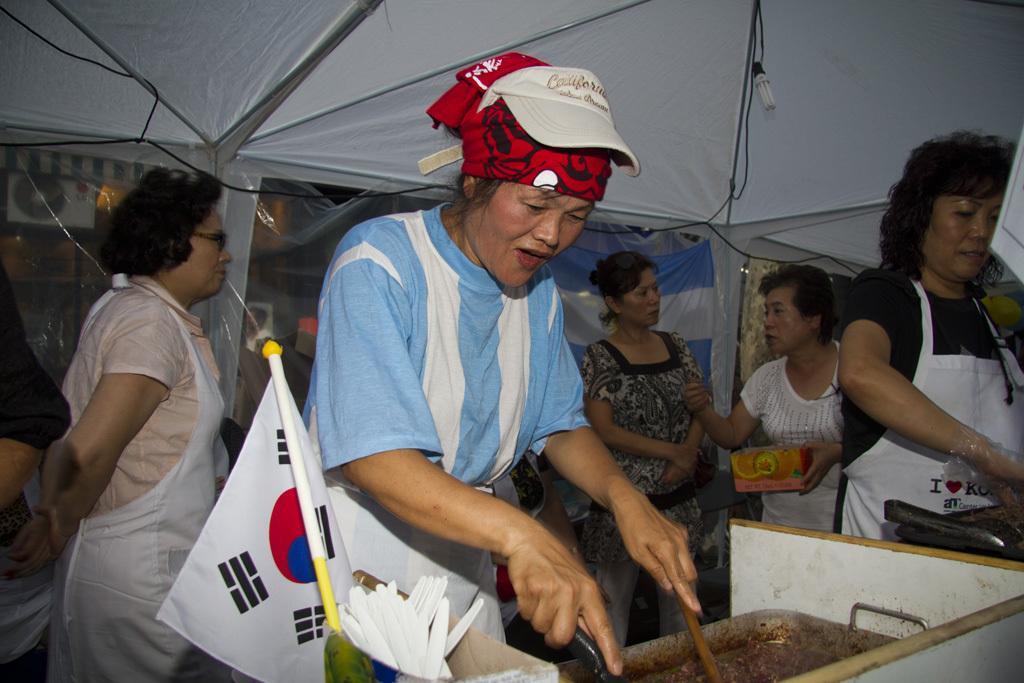How would you summarize this image in a sentence or two? As we can see in the image there is tent, light, flag, dish and few people. 